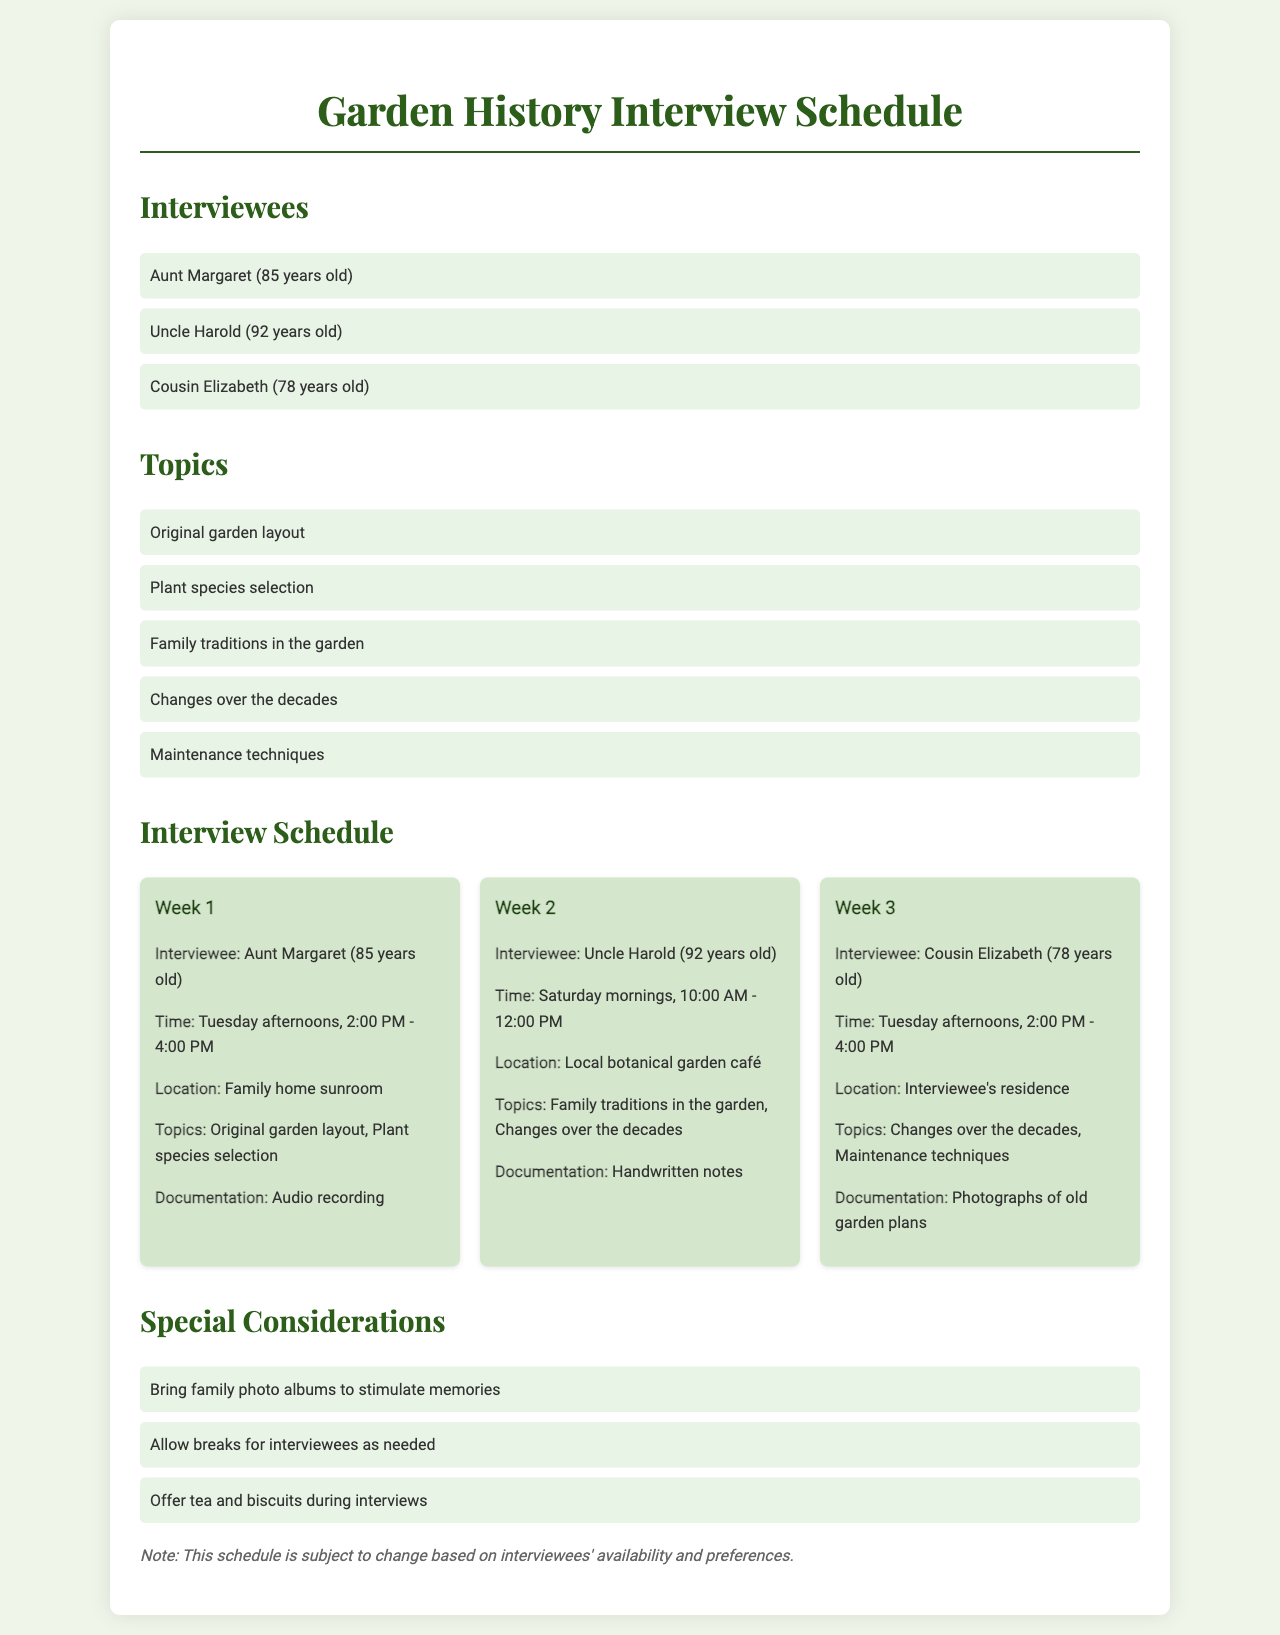What are the names of the interviewees? The document lists three interviewees: Aunt Margaret, Uncle Harold, and Cousin Elizabeth.
Answer: Aunt Margaret, Uncle Harold, Cousin Elizabeth How old is Uncle Harold? The document mentions Uncle Harold's age as part of his description.
Answer: 92 years old What are the scheduled times for interviews? The document provides two distinct time slots for the interviews.
Answer: Tuesday afternoons, 2:00 PM - 4:00 PM and Saturday mornings, 10:00 AM - 12:00 PM Which location is designated for the first interview? The document specifies the location for the first interview, held with Aunt Margaret.
Answer: Family home sunroom What documentation method will be used in Week 2? The document states that the documentation method for Week 2 includes handwritten notes.
Answer: Handwritten notes Which topic relates to the changes in the garden? The document outlines several topics, and one specifically mentions changes over time.
Answer: Changes over the decades How many family traditions in the garden are listed as topics? The document mentions a specific topic under family traditions that will be addressed during the interviews.
Answer: One What is a special consideration for the interviews? The document includes specific suggestions to enhance the interview experience, one being the offering of refreshments.
Answer: Offer tea and biscuits during interviews Which interviewee is scheduled for Week 3? The document clearly indicates the interviewee for Week 3 in the schedule section.
Answer: Cousin Elizabeth 